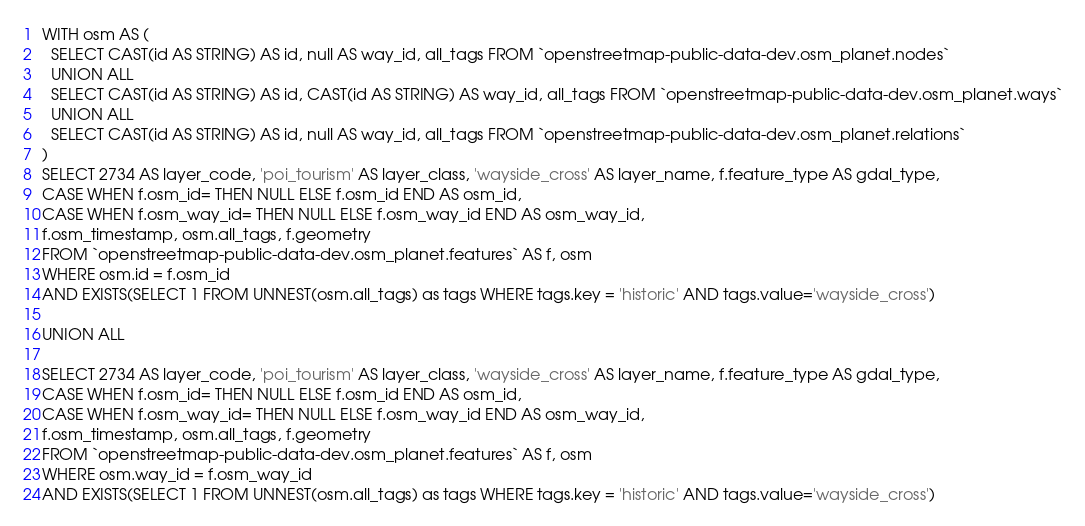<code> <loc_0><loc_0><loc_500><loc_500><_SQL_>
WITH osm AS (
  SELECT CAST(id AS STRING) AS id, null AS way_id, all_tags FROM `openstreetmap-public-data-dev.osm_planet.nodes`
  UNION ALL
  SELECT CAST(id AS STRING) AS id, CAST(id AS STRING) AS way_id, all_tags FROM `openstreetmap-public-data-dev.osm_planet.ways`
  UNION ALL
  SELECT CAST(id AS STRING) AS id, null AS way_id, all_tags FROM `openstreetmap-public-data-dev.osm_planet.relations`
)
SELECT 2734 AS layer_code, 'poi_tourism' AS layer_class, 'wayside_cross' AS layer_name, f.feature_type AS gdal_type,
CASE WHEN f.osm_id= THEN NULL ELSE f.osm_id END AS osm_id,
CASE WHEN f.osm_way_id= THEN NULL ELSE f.osm_way_id END AS osm_way_id,
f.osm_timestamp, osm.all_tags, f.geometry
FROM `openstreetmap-public-data-dev.osm_planet.features` AS f, osm
WHERE osm.id = f.osm_id
AND EXISTS(SELECT 1 FROM UNNEST(osm.all_tags) as tags WHERE tags.key = 'historic' AND tags.value='wayside_cross')

UNION ALL

SELECT 2734 AS layer_code, 'poi_tourism' AS layer_class, 'wayside_cross' AS layer_name, f.feature_type AS gdal_type,
CASE WHEN f.osm_id= THEN NULL ELSE f.osm_id END AS osm_id,
CASE WHEN f.osm_way_id= THEN NULL ELSE f.osm_way_id END AS osm_way_id,
f.osm_timestamp, osm.all_tags, f.geometry
FROM `openstreetmap-public-data-dev.osm_planet.features` AS f, osm
WHERE osm.way_id = f.osm_way_id
AND EXISTS(SELECT 1 FROM UNNEST(osm.all_tags) as tags WHERE tags.key = 'historic' AND tags.value='wayside_cross')

</code> 